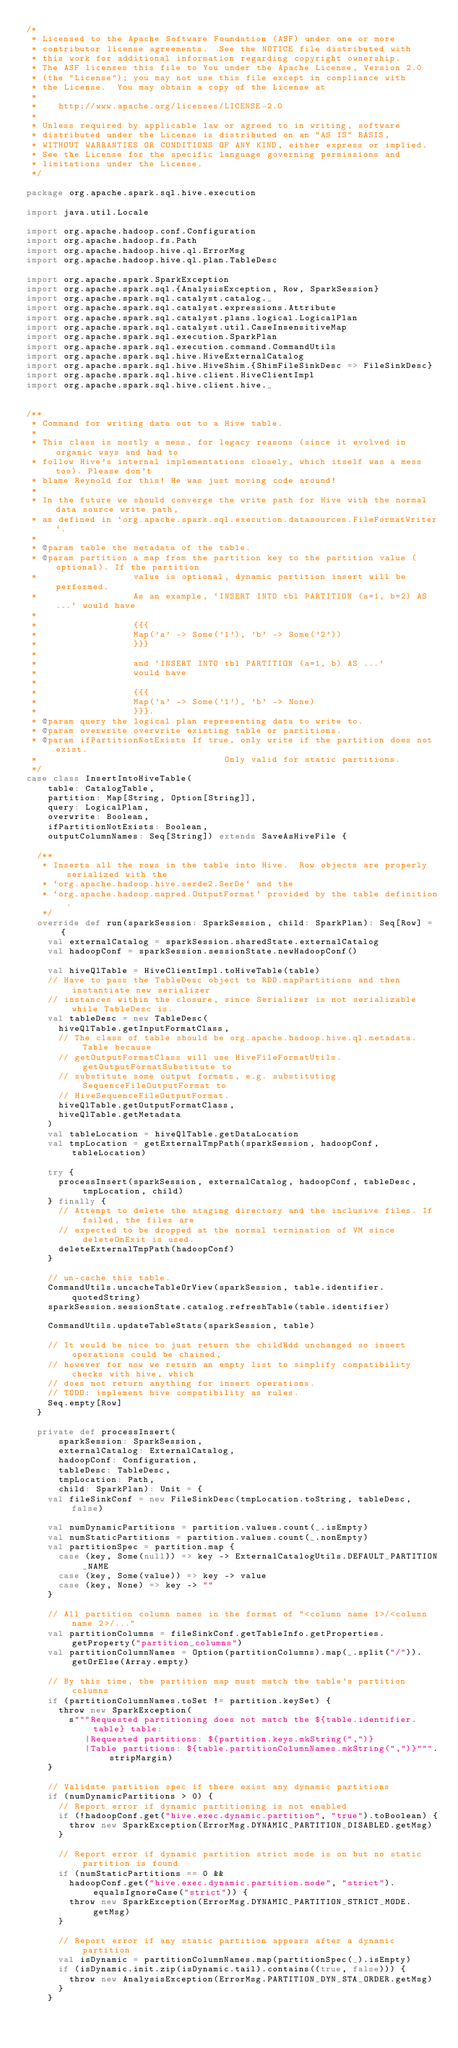<code> <loc_0><loc_0><loc_500><loc_500><_Scala_>/*
 * Licensed to the Apache Software Foundation (ASF) under one or more
 * contributor license agreements.  See the NOTICE file distributed with
 * this work for additional information regarding copyright ownership.
 * The ASF licenses this file to You under the Apache License, Version 2.0
 * (the "License"); you may not use this file except in compliance with
 * the License.  You may obtain a copy of the License at
 *
 *    http://www.apache.org/licenses/LICENSE-2.0
 *
 * Unless required by applicable law or agreed to in writing, software
 * distributed under the License is distributed on an "AS IS" BASIS,
 * WITHOUT WARRANTIES OR CONDITIONS OF ANY KIND, either express or implied.
 * See the License for the specific language governing permissions and
 * limitations under the License.
 */

package org.apache.spark.sql.hive.execution

import java.util.Locale

import org.apache.hadoop.conf.Configuration
import org.apache.hadoop.fs.Path
import org.apache.hadoop.hive.ql.ErrorMsg
import org.apache.hadoop.hive.ql.plan.TableDesc

import org.apache.spark.SparkException
import org.apache.spark.sql.{AnalysisException, Row, SparkSession}
import org.apache.spark.sql.catalyst.catalog._
import org.apache.spark.sql.catalyst.expressions.Attribute
import org.apache.spark.sql.catalyst.plans.logical.LogicalPlan
import org.apache.spark.sql.catalyst.util.CaseInsensitiveMap
import org.apache.spark.sql.execution.SparkPlan
import org.apache.spark.sql.execution.command.CommandUtils
import org.apache.spark.sql.hive.HiveExternalCatalog
import org.apache.spark.sql.hive.HiveShim.{ShimFileSinkDesc => FileSinkDesc}
import org.apache.spark.sql.hive.client.HiveClientImpl
import org.apache.spark.sql.hive.client.hive._


/**
 * Command for writing data out to a Hive table.
 *
 * This class is mostly a mess, for legacy reasons (since it evolved in organic ways and had to
 * follow Hive's internal implementations closely, which itself was a mess too). Please don't
 * blame Reynold for this! He was just moving code around!
 *
 * In the future we should converge the write path for Hive with the normal data source write path,
 * as defined in `org.apache.spark.sql.execution.datasources.FileFormatWriter`.
 *
 * @param table the metadata of the table.
 * @param partition a map from the partition key to the partition value (optional). If the partition
 *                  value is optional, dynamic partition insert will be performed.
 *                  As an example, `INSERT INTO tbl PARTITION (a=1, b=2) AS ...` would have
 *
 *                  {{{
 *                  Map('a' -> Some('1'), 'b' -> Some('2'))
 *                  }}}
 *
 *                  and `INSERT INTO tbl PARTITION (a=1, b) AS ...`
 *                  would have
 *
 *                  {{{
 *                  Map('a' -> Some('1'), 'b' -> None)
 *                  }}}.
 * @param query the logical plan representing data to write to.
 * @param overwrite overwrite existing table or partitions.
 * @param ifPartitionNotExists If true, only write if the partition does not exist.
 *                                   Only valid for static partitions.
 */
case class InsertIntoHiveTable(
    table: CatalogTable,
    partition: Map[String, Option[String]],
    query: LogicalPlan,
    overwrite: Boolean,
    ifPartitionNotExists: Boolean,
    outputColumnNames: Seq[String]) extends SaveAsHiveFile {

  /**
   * Inserts all the rows in the table into Hive.  Row objects are properly serialized with the
   * `org.apache.hadoop.hive.serde2.SerDe` and the
   * `org.apache.hadoop.mapred.OutputFormat` provided by the table definition.
   */
  override def run(sparkSession: SparkSession, child: SparkPlan): Seq[Row] = {
    val externalCatalog = sparkSession.sharedState.externalCatalog
    val hadoopConf = sparkSession.sessionState.newHadoopConf()

    val hiveQlTable = HiveClientImpl.toHiveTable(table)
    // Have to pass the TableDesc object to RDD.mapPartitions and then instantiate new serializer
    // instances within the closure, since Serializer is not serializable while TableDesc is.
    val tableDesc = new TableDesc(
      hiveQlTable.getInputFormatClass,
      // The class of table should be org.apache.hadoop.hive.ql.metadata.Table because
      // getOutputFormatClass will use HiveFileFormatUtils.getOutputFormatSubstitute to
      // substitute some output formats, e.g. substituting SequenceFileOutputFormat to
      // HiveSequenceFileOutputFormat.
      hiveQlTable.getOutputFormatClass,
      hiveQlTable.getMetadata
    )
    val tableLocation = hiveQlTable.getDataLocation
    val tmpLocation = getExternalTmpPath(sparkSession, hadoopConf, tableLocation)

    try {
      processInsert(sparkSession, externalCatalog, hadoopConf, tableDesc, tmpLocation, child)
    } finally {
      // Attempt to delete the staging directory and the inclusive files. If failed, the files are
      // expected to be dropped at the normal termination of VM since deleteOnExit is used.
      deleteExternalTmpPath(hadoopConf)
    }

    // un-cache this table.
    CommandUtils.uncacheTableOrView(sparkSession, table.identifier.quotedString)
    sparkSession.sessionState.catalog.refreshTable(table.identifier)

    CommandUtils.updateTableStats(sparkSession, table)

    // It would be nice to just return the childRdd unchanged so insert operations could be chained,
    // however for now we return an empty list to simplify compatibility checks with hive, which
    // does not return anything for insert operations.
    // TODO: implement hive compatibility as rules.
    Seq.empty[Row]
  }

  private def processInsert(
      sparkSession: SparkSession,
      externalCatalog: ExternalCatalog,
      hadoopConf: Configuration,
      tableDesc: TableDesc,
      tmpLocation: Path,
      child: SparkPlan): Unit = {
    val fileSinkConf = new FileSinkDesc(tmpLocation.toString, tableDesc, false)

    val numDynamicPartitions = partition.values.count(_.isEmpty)
    val numStaticPartitions = partition.values.count(_.nonEmpty)
    val partitionSpec = partition.map {
      case (key, Some(null)) => key -> ExternalCatalogUtils.DEFAULT_PARTITION_NAME
      case (key, Some(value)) => key -> value
      case (key, None) => key -> ""
    }

    // All partition column names in the format of "<column name 1>/<column name 2>/..."
    val partitionColumns = fileSinkConf.getTableInfo.getProperties.getProperty("partition_columns")
    val partitionColumnNames = Option(partitionColumns).map(_.split("/")).getOrElse(Array.empty)

    // By this time, the partition map must match the table's partition columns
    if (partitionColumnNames.toSet != partition.keySet) {
      throw new SparkException(
        s"""Requested partitioning does not match the ${table.identifier.table} table:
           |Requested partitions: ${partition.keys.mkString(",")}
           |Table partitions: ${table.partitionColumnNames.mkString(",")}""".stripMargin)
    }

    // Validate partition spec if there exist any dynamic partitions
    if (numDynamicPartitions > 0) {
      // Report error if dynamic partitioning is not enabled
      if (!hadoopConf.get("hive.exec.dynamic.partition", "true").toBoolean) {
        throw new SparkException(ErrorMsg.DYNAMIC_PARTITION_DISABLED.getMsg)
      }

      // Report error if dynamic partition strict mode is on but no static partition is found
      if (numStaticPartitions == 0 &&
        hadoopConf.get("hive.exec.dynamic.partition.mode", "strict").equalsIgnoreCase("strict")) {
        throw new SparkException(ErrorMsg.DYNAMIC_PARTITION_STRICT_MODE.getMsg)
      }

      // Report error if any static partition appears after a dynamic partition
      val isDynamic = partitionColumnNames.map(partitionSpec(_).isEmpty)
      if (isDynamic.init.zip(isDynamic.tail).contains((true, false))) {
        throw new AnalysisException(ErrorMsg.PARTITION_DYN_STA_ORDER.getMsg)
      }
    }
</code> 